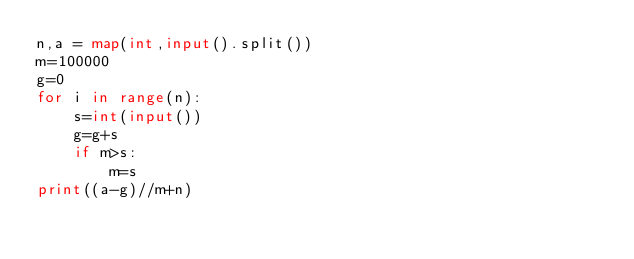Convert code to text. <code><loc_0><loc_0><loc_500><loc_500><_Python_>n,a = map(int,input().split())
m=100000
g=0
for i in range(n):
    s=int(input())
    g=g+s
    if m>s:
        m=s
print((a-g)//m+n)</code> 